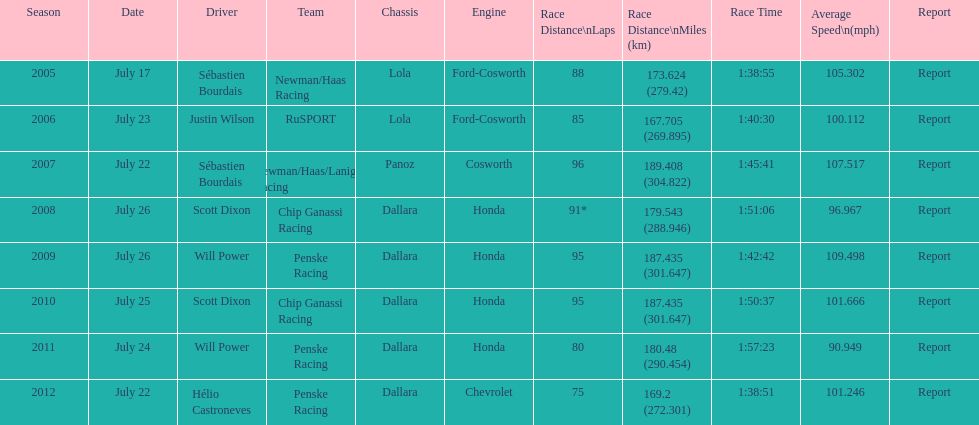What is the least amount of laps completed? 75. 